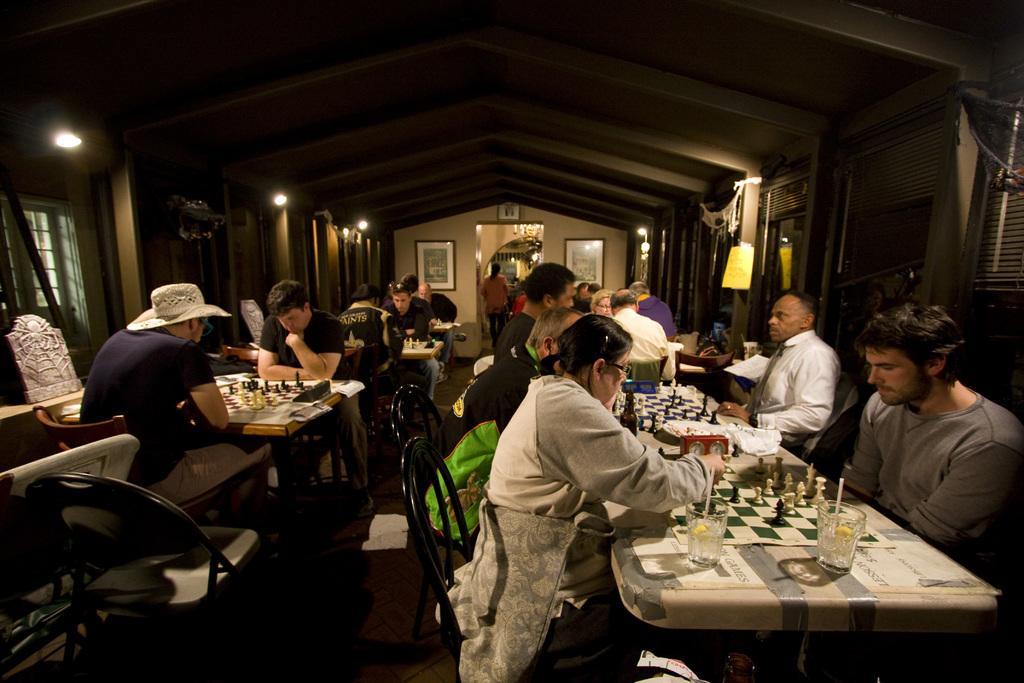In one or two sentences, can you explain what this image depicts? Here we can see a group of people siting on the chair, and in front here is the table and glass and some objects on it, and here is the wall and photo frame on it, and at side here is the door. 